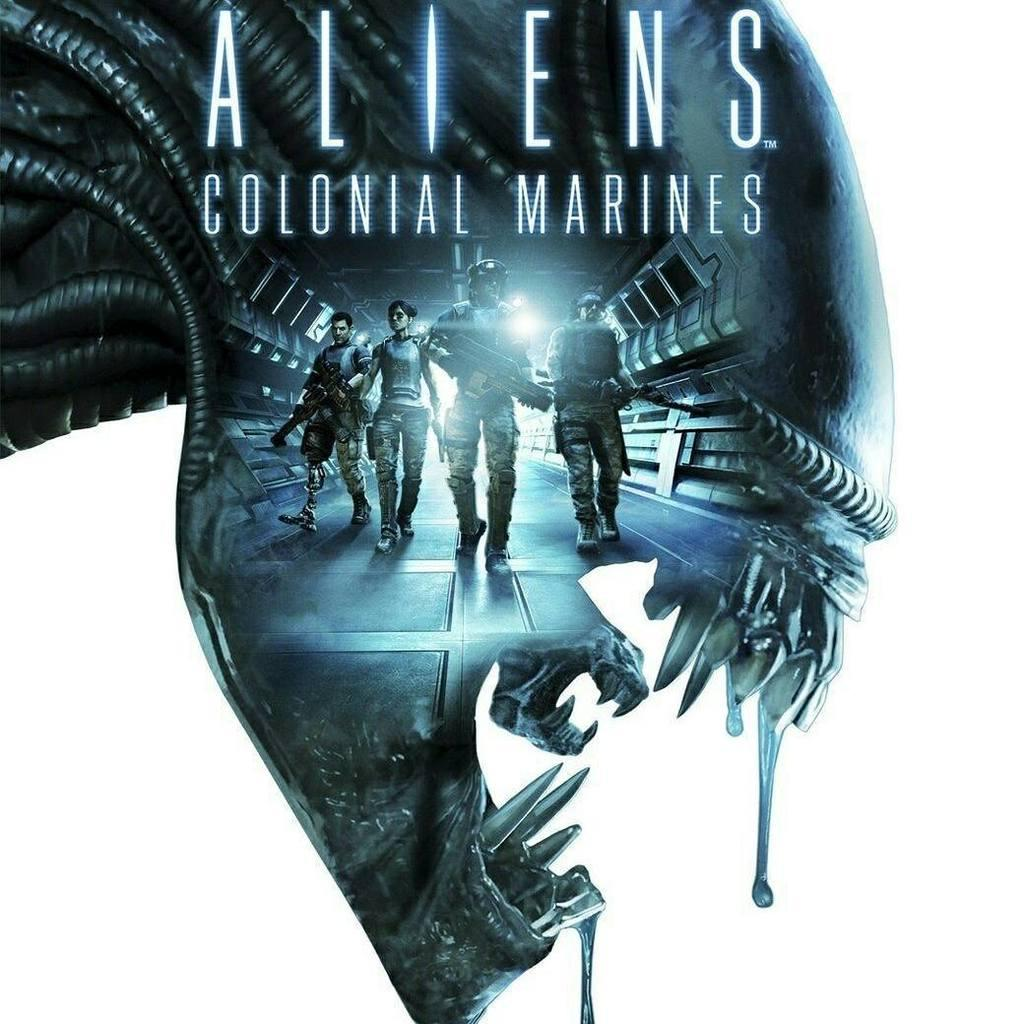<image>
Create a compact narrative representing the image presented. the cover art for the video game aliens colonial marines. 